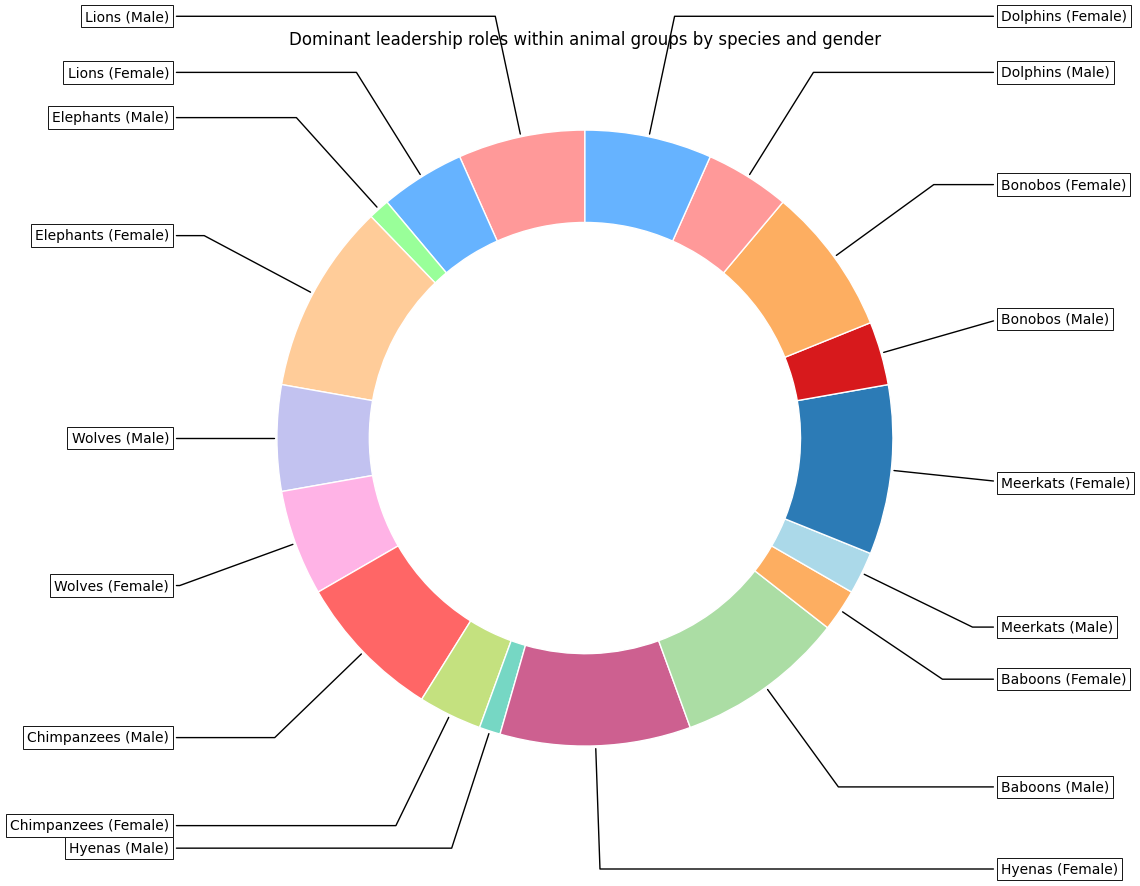What's the species with the highest percentage of dominant female leadership? Look for the species segment where the female leadership percentage is highest. In this case, Elephants and Hyenas both have 90% female leadership.
Answer: Elephants, Hyenas Which species has a perfectly equal split in gender leadership roles? Identify the species for which male and female leadership percentages are equal. The "Wolves" segment shows a 50/50 split on the chart.
Answer: Wolves What's the combined percentage of female leadership in Lions and Baboons? Sum the female leadership percentages of Lions (40%) and Baboons (20%). 40% + 20% = 60%
Answer: 60% How does male leadership in Chimpanzees compare to female leadership in Meerkats? Compare the two percentages. Chimpanzees have 70% male leadership and Meerkats have 80% female leadership. Male leadership in Chimpanzees is less than female leadership in Meerkats.
Answer: Male leadership in Chimpanzees is less Among dolphins, is male or female leadership higher? Compare the percentages for Dolphins. Male leadership is 40% and female leadership is 60%, so female leadership is higher.
Answer: Female leadership Which species shows the largest disparity between male and female leadership roles? Calculate the absolute differences between male and female leadership for each species and identify the largest. Baboons have an 80% male vs. 20% female disparity, which is 60%.
Answer: Baboons What is the average percentage of female leadership roles across all species? Sum the percentages of female leadership across all species and divide by the number of species. (40 + 90 + 50 + 30 + 90 + 20 + 80 + 70 + 60) / 9 = 53.33%
Answer: 53.33% Which two species both have exactly the same female leadership percentage? Look for species with identical percentages of female leadership. Elephants and Hyenas both show 90% female leadership.
Answer: Elephants, Hyenas How much higher is male leadership in Baboons compared to Bonobos? Subtract the percentage of male leadership in Bonobos from Baboons. 80% (Baboons) - 30% (Bonobos) = 50%
Answer: 50% What percentage of total leadership roles is held by females in Elephants, Hyenas, and Bonobos combined? Sum the female leadership percentages for Elephants (90%), Hyenas (90%), and Bonobos (70%). 90% + 90% + 70% = 250%
Answer: 250% 